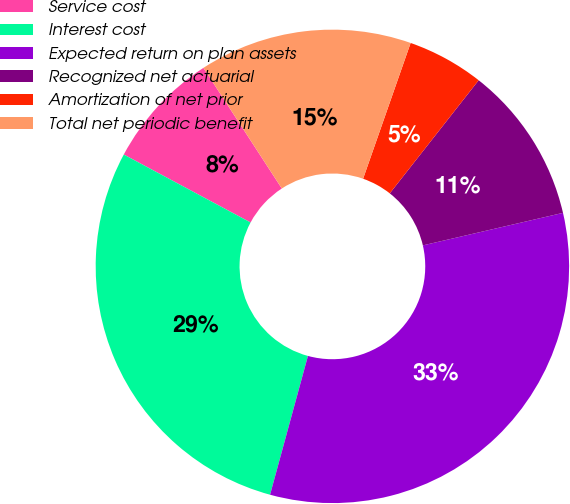Convert chart to OTSL. <chart><loc_0><loc_0><loc_500><loc_500><pie_chart><fcel>Service cost<fcel>Interest cost<fcel>Expected return on plan assets<fcel>Recognized net actuarial<fcel>Amortization of net prior<fcel>Total net periodic benefit<nl><fcel>8.0%<fcel>28.59%<fcel>32.87%<fcel>10.77%<fcel>5.24%<fcel>14.53%<nl></chart> 